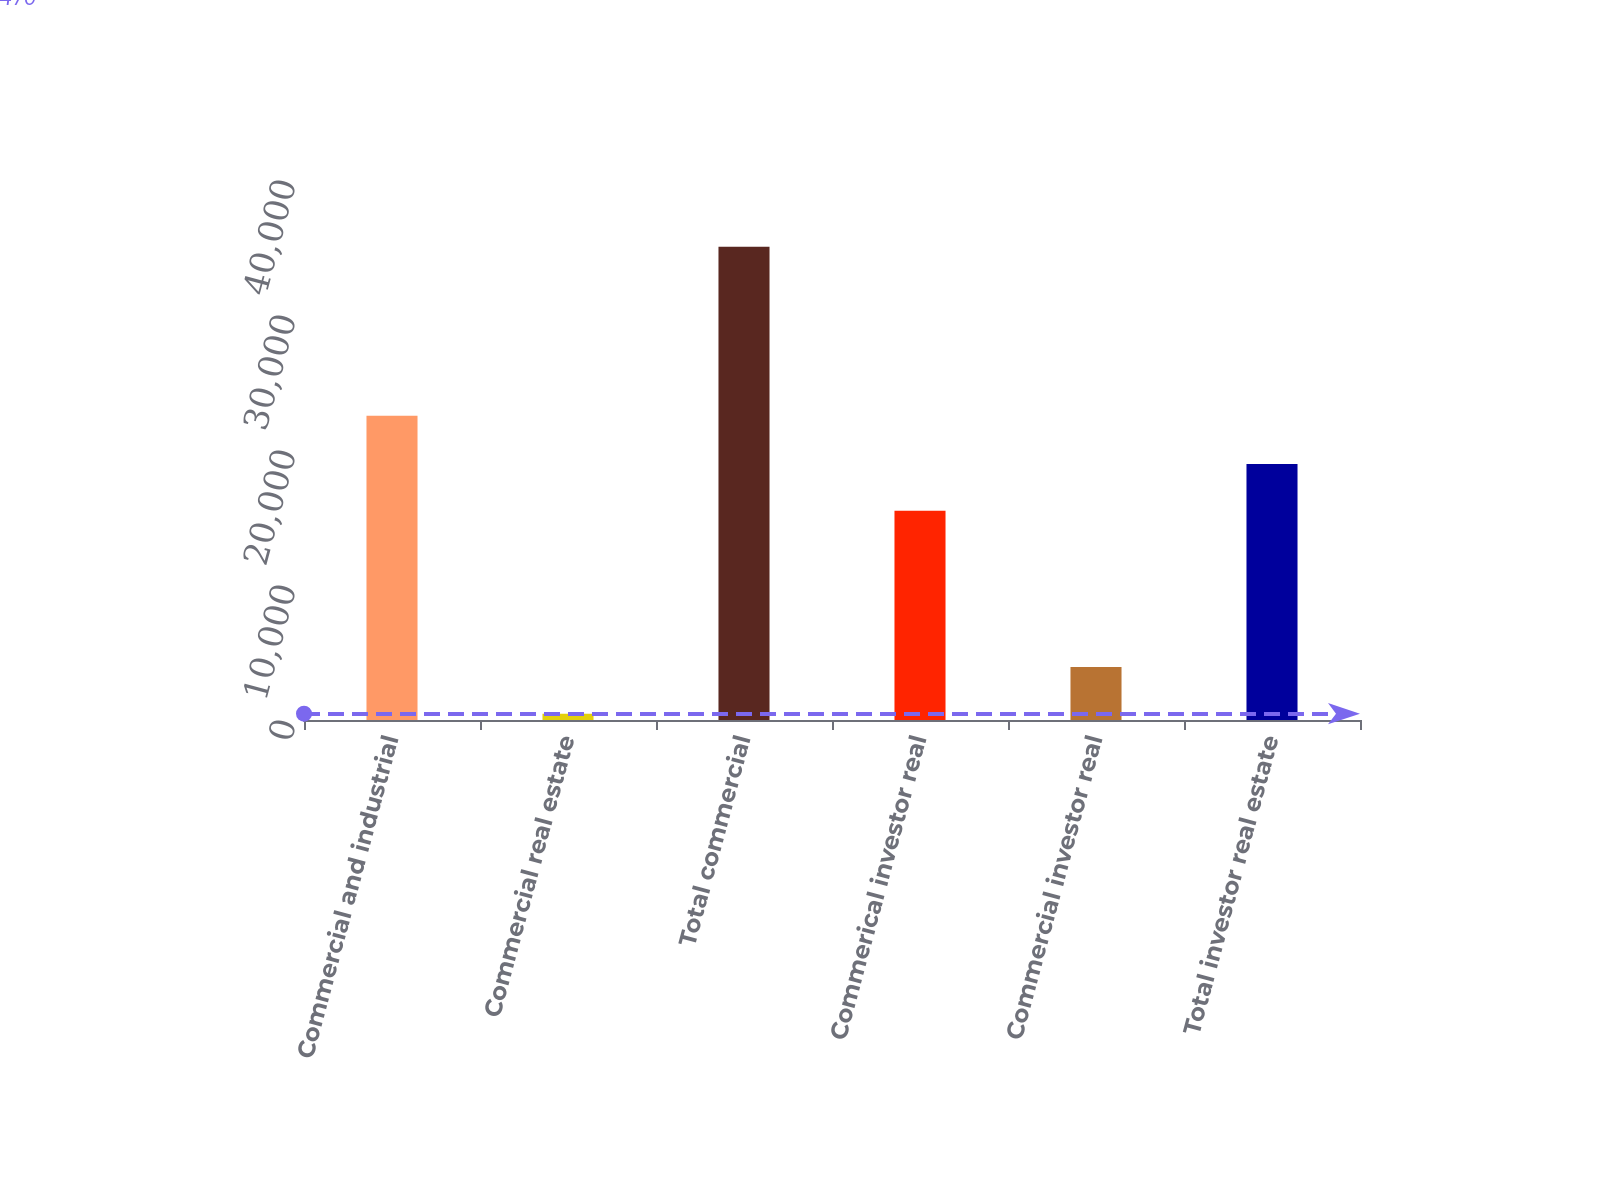Convert chart to OTSL. <chart><loc_0><loc_0><loc_500><loc_500><bar_chart><fcel>Commercial and industrial<fcel>Commercial real estate<fcel>Total commercial<fcel>Commerical investor real<fcel>Commercial investor real<fcel>Total investor real estate<nl><fcel>22540<fcel>470<fcel>35056<fcel>15504.6<fcel>3928.6<fcel>18963.2<nl></chart> 